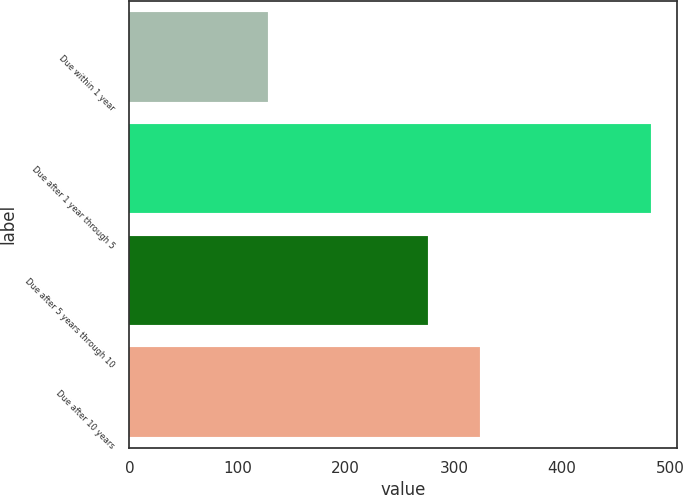Convert chart. <chart><loc_0><loc_0><loc_500><loc_500><bar_chart><fcel>Due within 1 year<fcel>Due after 1 year through 5<fcel>Due after 5 years through 10<fcel>Due after 10 years<nl><fcel>128.4<fcel>482.3<fcel>276<fcel>323.9<nl></chart> 